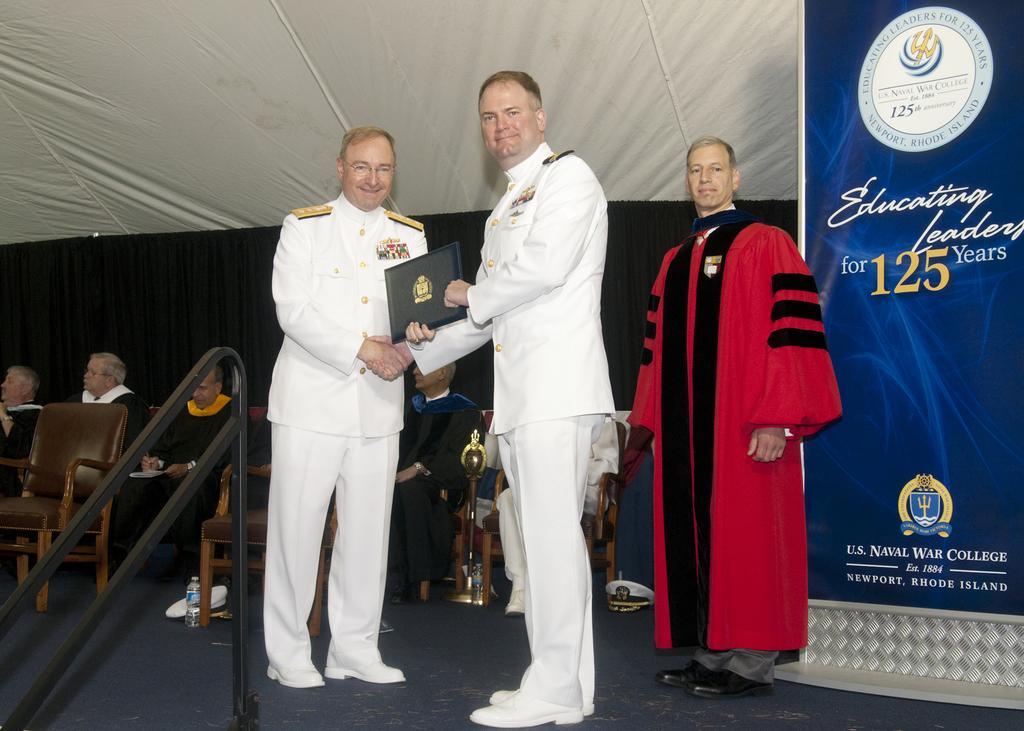How would you summarize this image in a sentence or two? Here in this picture in the front we can see two persons in navy dress standing on the stage, holding a certificate in between them and behind them we can see a person in a red and black colored suit present over there and beside them we can see number of people sitting on chairs over there and we can see a curtain and a banner also present over there. 